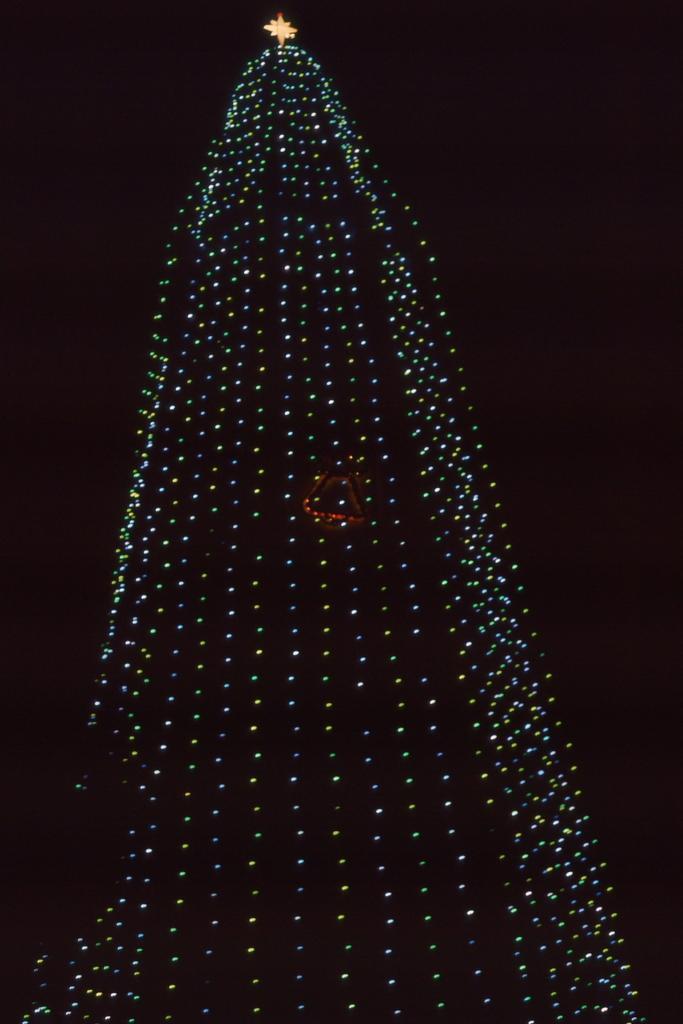Can you describe this image briefly? There are lights and a star on the top. The background is black. 